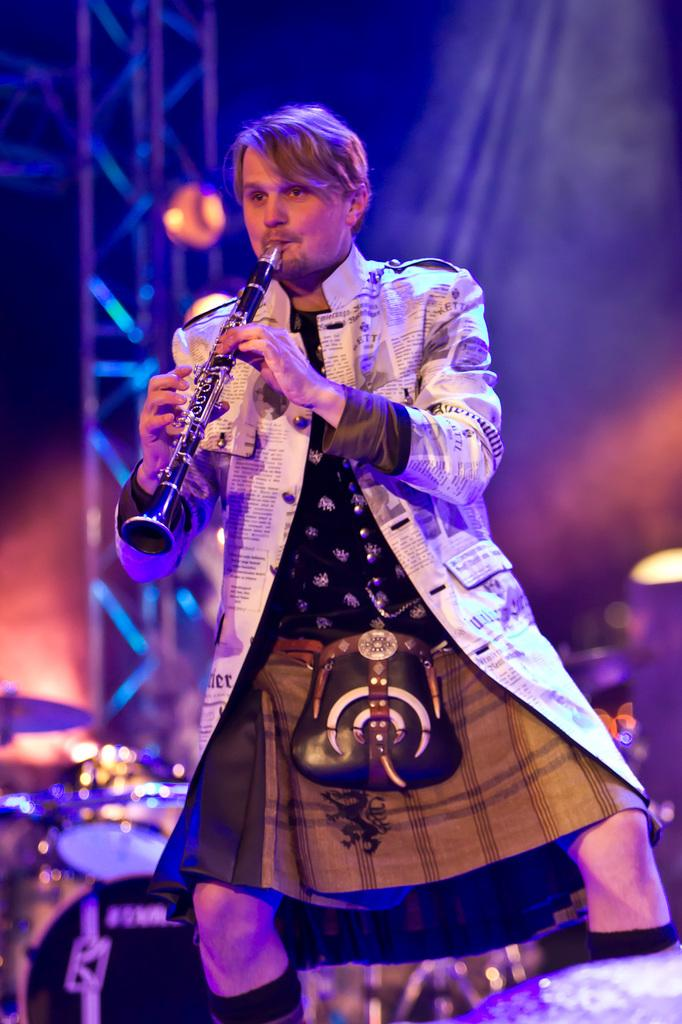Who or what is the main subject in the image? There is a person in the image. What is the person wearing? The person is wearing a different type of dress. What is the person doing in the image? The person is playing a musical instrument. Where is the rake being used in the image? There is no rake present in the image. What type of nest can be seen in the image? There is no nest present in the image. 